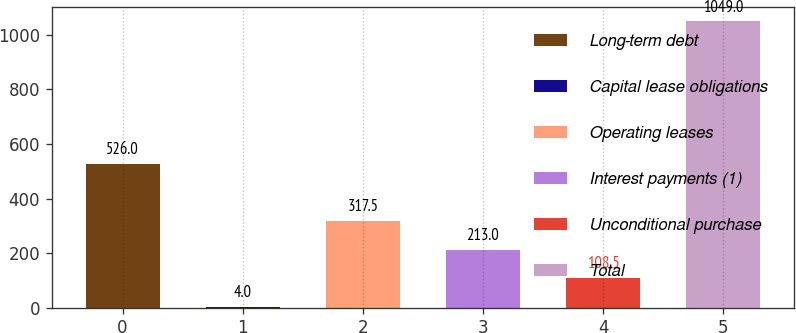Convert chart. <chart><loc_0><loc_0><loc_500><loc_500><bar_chart><fcel>Long-term debt<fcel>Capital lease obligations<fcel>Operating leases<fcel>Interest payments (1)<fcel>Unconditional purchase<fcel>Total<nl><fcel>526<fcel>4<fcel>317.5<fcel>213<fcel>108.5<fcel>1049<nl></chart> 